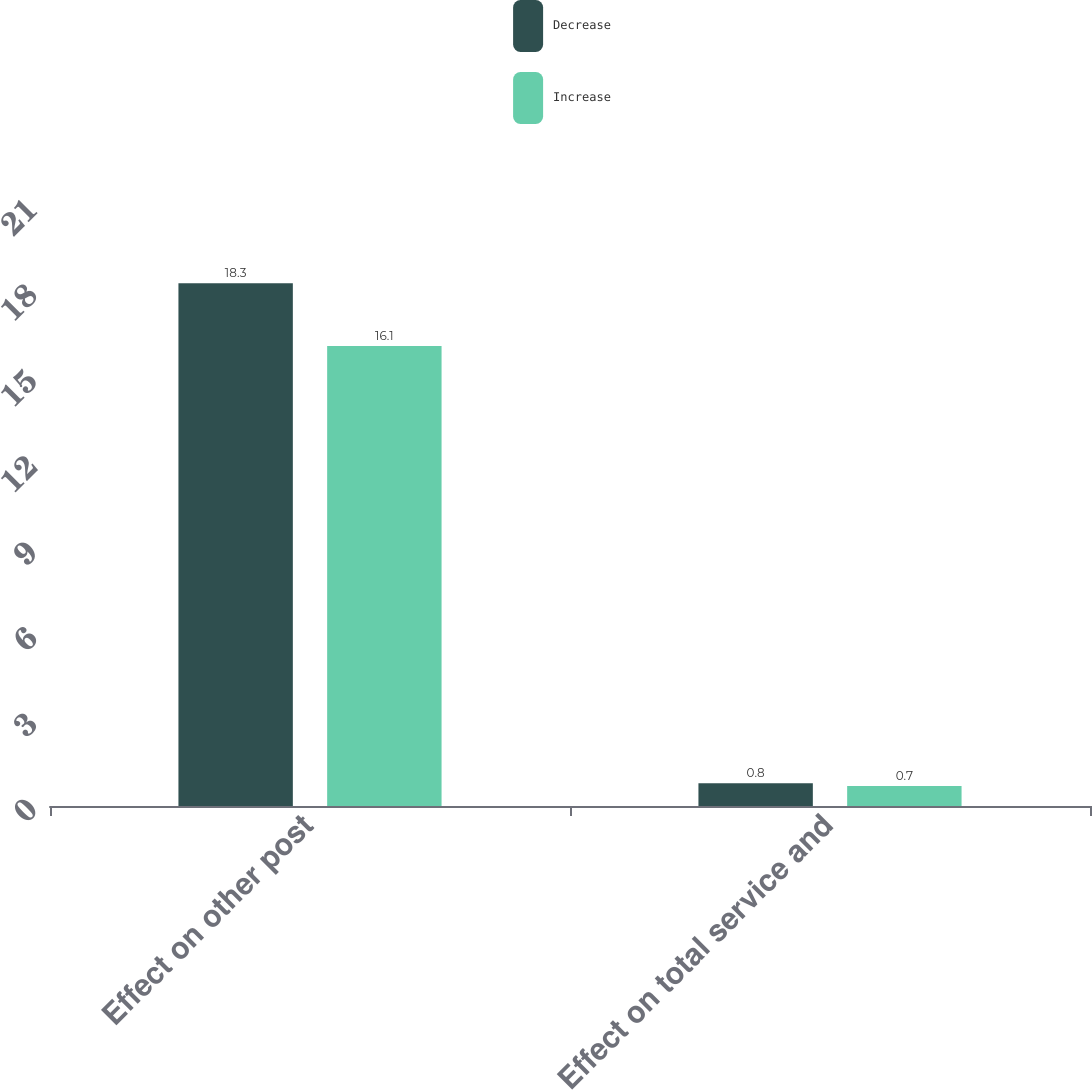Convert chart to OTSL. <chart><loc_0><loc_0><loc_500><loc_500><stacked_bar_chart><ecel><fcel>Effect on other post<fcel>Effect on total service and<nl><fcel>Decrease<fcel>18.3<fcel>0.8<nl><fcel>Increase<fcel>16.1<fcel>0.7<nl></chart> 